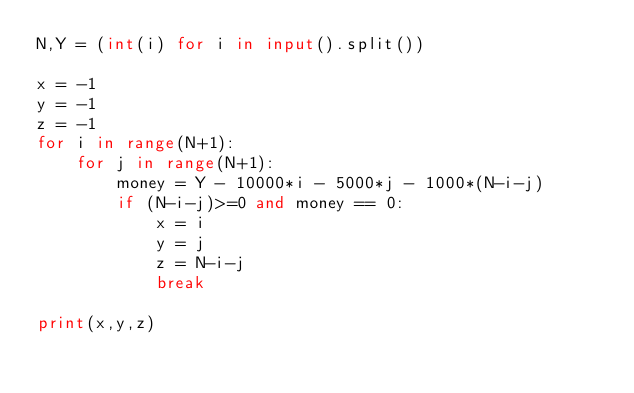Convert code to text. <code><loc_0><loc_0><loc_500><loc_500><_Python_>N,Y = (int(i) for i in input().split())

x = -1
y = -1
z = -1
for i in range(N+1):
    for j in range(N+1):
        money = Y - 10000*i - 5000*j - 1000*(N-i-j)
        if (N-i-j)>=0 and money == 0:
            x = i
            y = j
            z = N-i-j
            break

print(x,y,z)</code> 